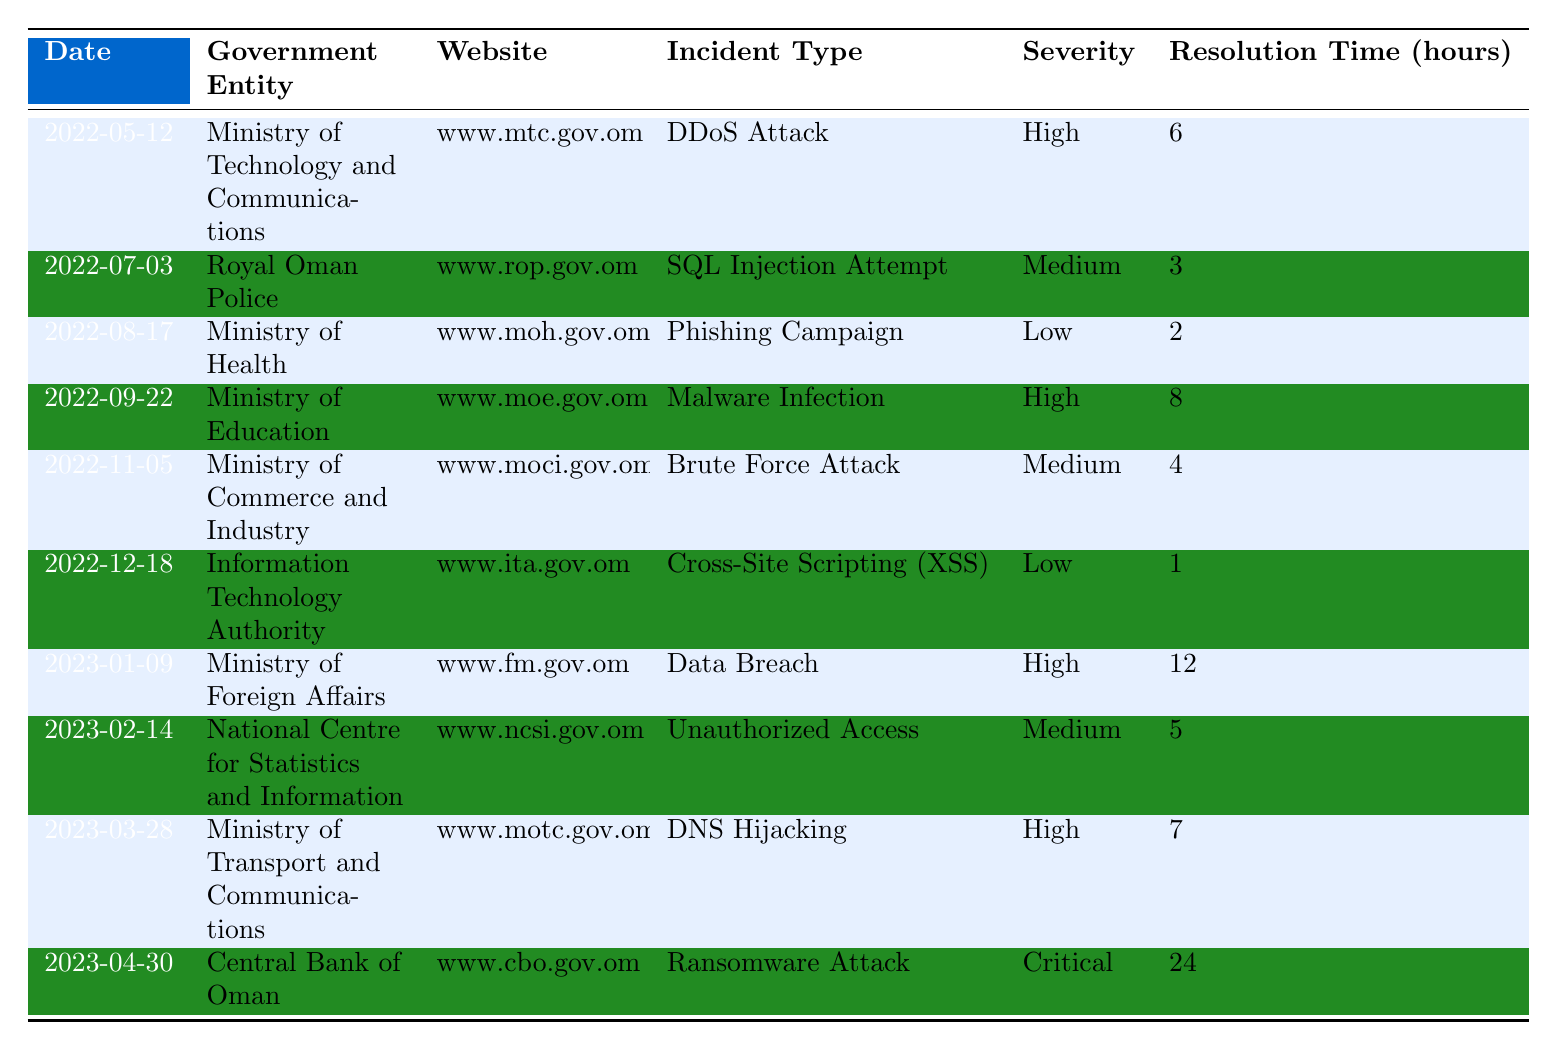What was the most severe incident reported in the table? The incident with the highest severity is the Ransomware Attack reported by the Central Bank of Oman on April 30, 2023, which is categorized as Critical.
Answer: Ransomware Attack How many incidents were classified as High severity? There are three incidents identified as High severity: the DDoS Attack, Malware Infection, and Data Breach.
Answer: 3 What is the average resolution time for incidents classified as Medium severity? The total resolution times for Medium severity incidents are 3, 4, and 5 hours, which sums to 12 hours. Since there are three incidents, the average resolution time is 12 hours / 3 = 4 hours.
Answer: 4 hours Did any government entity report more than one cybersecurity incident in the table? No, each government entity in the table reported only one incident; therefore, there are no repeat reports.
Answer: No Which incident took the longest to resolve? The incident that took the longest to resolve was the Ransomware Attack, taking 24 hours.
Answer: Ransomware Attack What type of incident was reported by the Ministry of Foreign Affairs? The Ministry of Foreign Affairs reported a Data Breach.
Answer: Data Breach How many incidents occurred between May 2022 and December 2022? There were five reported incidents between May 2022 and December 2022: one each in May, July, August, September, November, and December.
Answer: 5 What is the total number of incidents reported across all entities in the table? There are ten incidents listed in the table overall, spanning from May 2022 to April 2023.
Answer: 10 What was the incident type with the lowest severity? The incident with the lowest severity was the Phishing Campaign reported by the Ministry of Health, classified as Low severity.
Answer: Phishing Campaign Which government entity had the incident with the shortest resolution time? The Information Technology Authority had the incident with the shortest resolution time, which was 1 hour for Cross-Site Scripting (XSS).
Answer: Information Technology Authority 